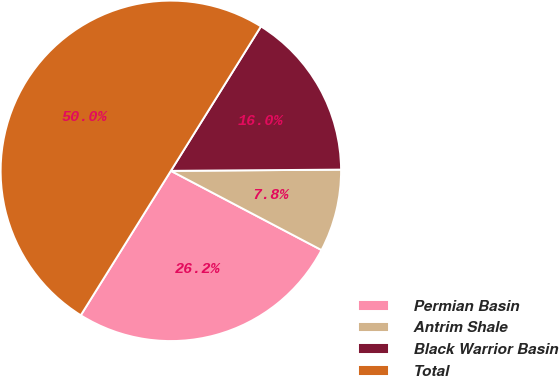<chart> <loc_0><loc_0><loc_500><loc_500><pie_chart><fcel>Permian Basin<fcel>Antrim Shale<fcel>Black Warrior Basin<fcel>Total<nl><fcel>26.17%<fcel>7.82%<fcel>16.01%<fcel>50.0%<nl></chart> 